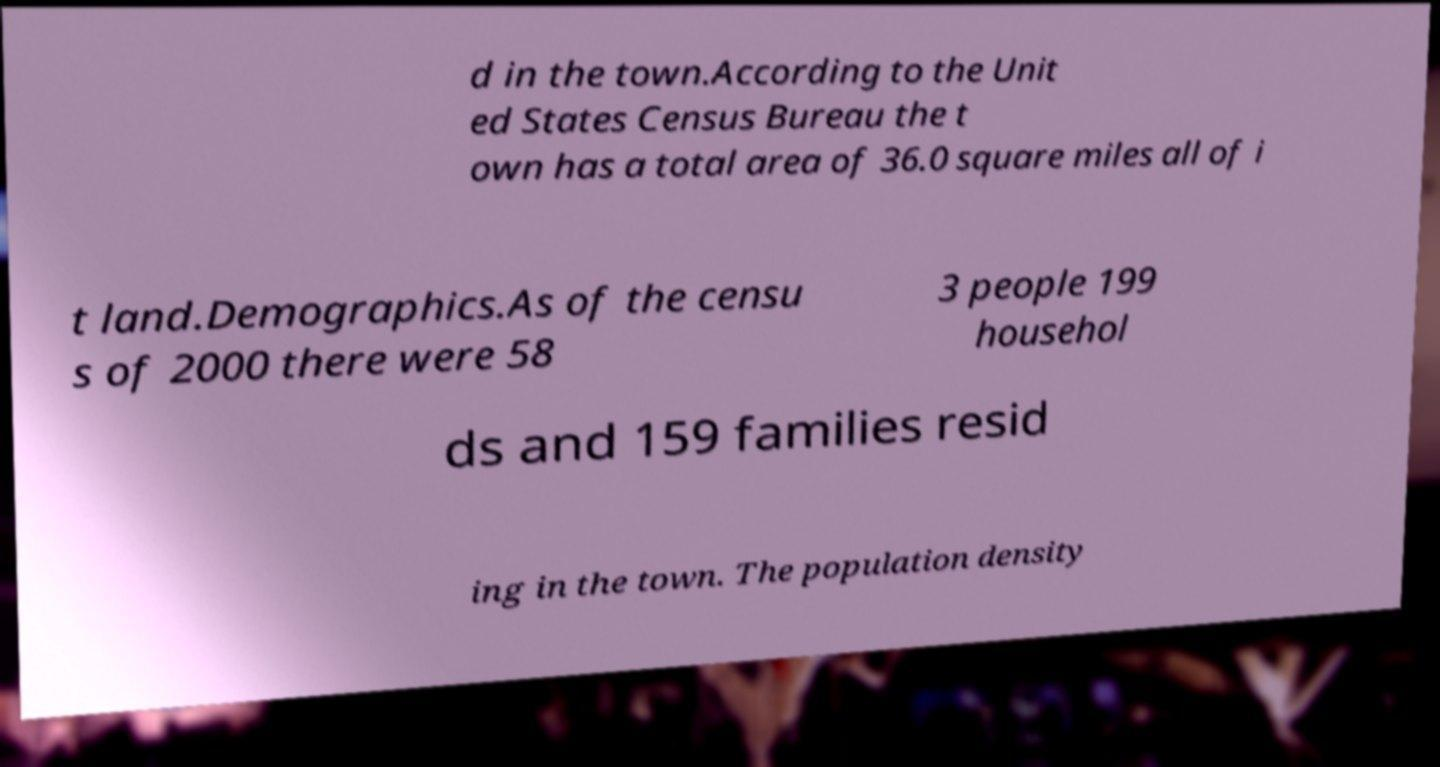There's text embedded in this image that I need extracted. Can you transcribe it verbatim? d in the town.According to the Unit ed States Census Bureau the t own has a total area of 36.0 square miles all of i t land.Demographics.As of the censu s of 2000 there were 58 3 people 199 househol ds and 159 families resid ing in the town. The population density 